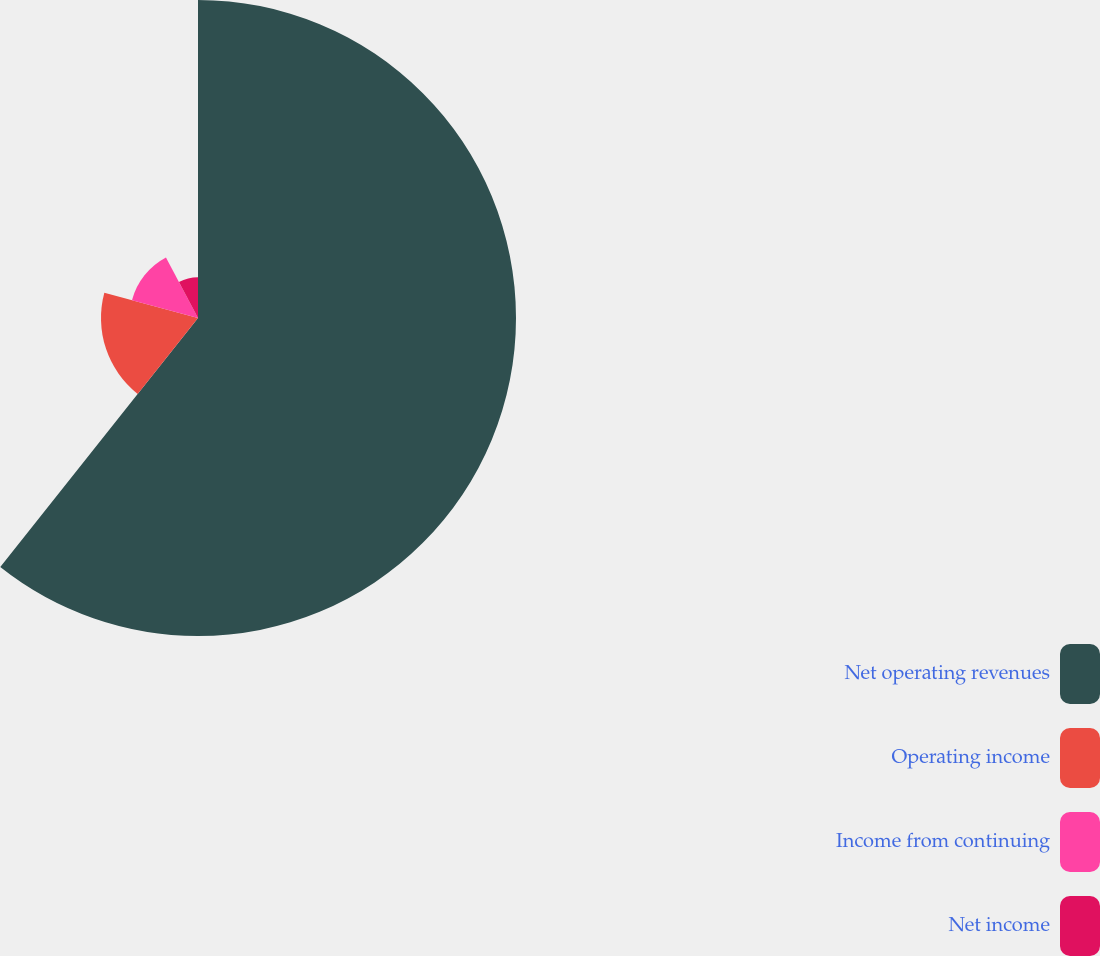Convert chart to OTSL. <chart><loc_0><loc_0><loc_500><loc_500><pie_chart><fcel>Net operating revenues<fcel>Operating income<fcel>Income from continuing<fcel>Net income<nl><fcel>60.68%<fcel>18.51%<fcel>13.05%<fcel>7.76%<nl></chart> 